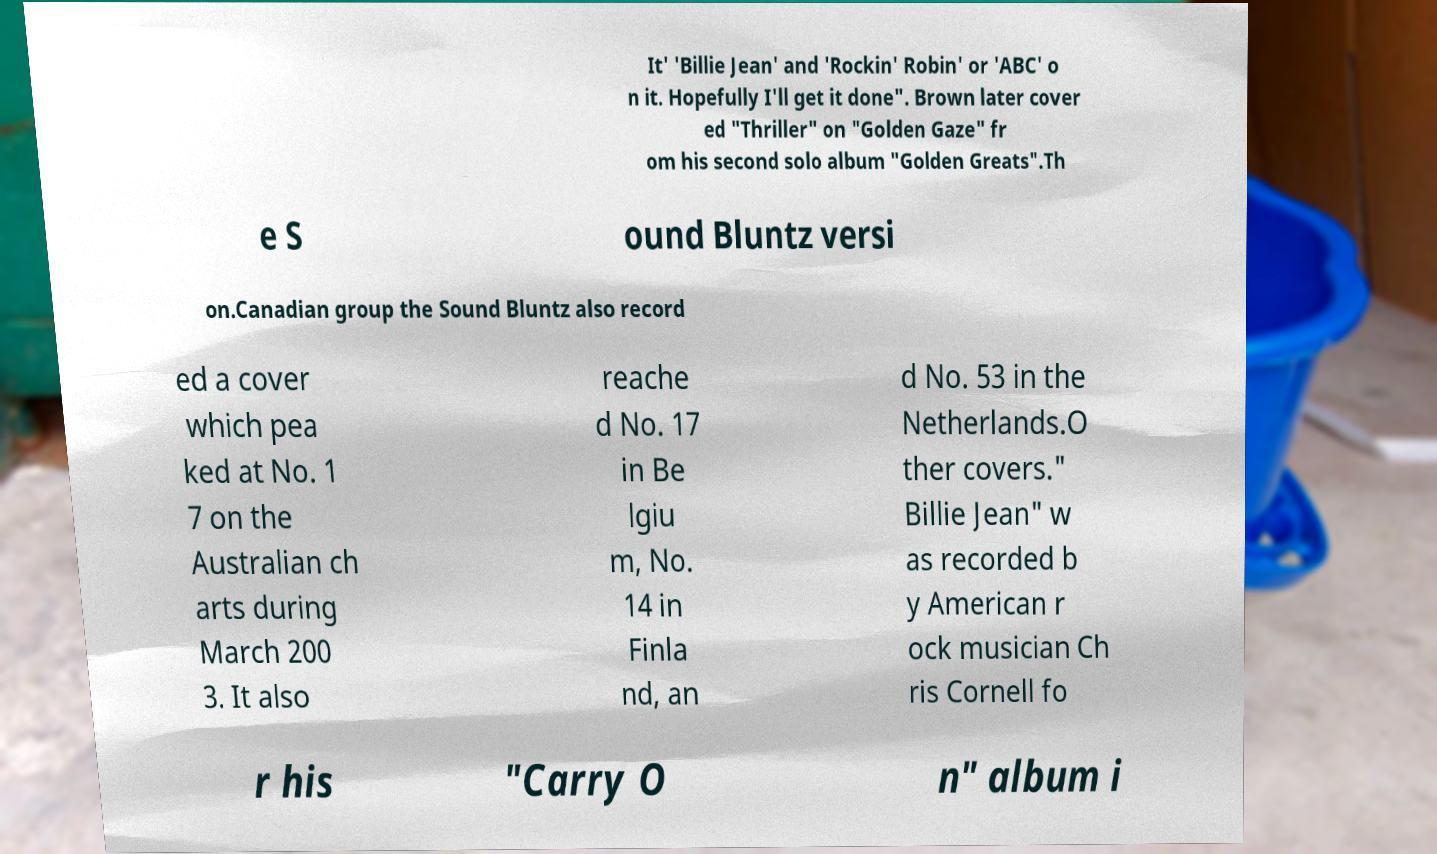What messages or text are displayed in this image? I need them in a readable, typed format. It' 'Billie Jean' and 'Rockin' Robin' or 'ABC' o n it. Hopefully I'll get it done". Brown later cover ed "Thriller" on "Golden Gaze" fr om his second solo album "Golden Greats".Th e S ound Bluntz versi on.Canadian group the Sound Bluntz also record ed a cover which pea ked at No. 1 7 on the Australian ch arts during March 200 3. It also reache d No. 17 in Be lgiu m, No. 14 in Finla nd, an d No. 53 in the Netherlands.O ther covers." Billie Jean" w as recorded b y American r ock musician Ch ris Cornell fo r his "Carry O n" album i 